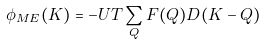<formula> <loc_0><loc_0><loc_500><loc_500>\phi _ { M E } ( K ) = - U T \sum _ { Q } F ( Q ) D ( K - Q )</formula> 